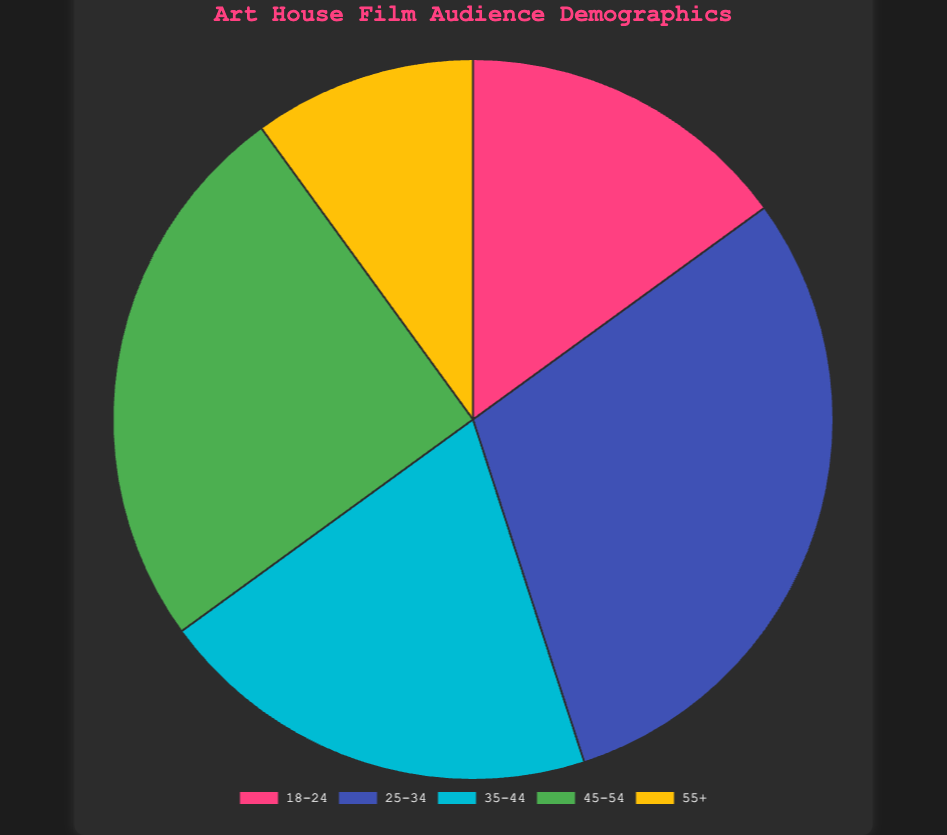What age group has the highest percentage in the audience demographic? The category with the highest percentage is "25-34" with 30%.
Answer: 25-34 Which age group has the smallest representation in the audience demographic? The category with the smallest percentage is "55+" with 10%.
Answer: 55+ What is the combined percentage of the "18-24" and "35-44" age groups? The "18-24" age group is 15% and the "35-44" age group is 20%. Combining these two percentages: 15% + 20% = 35%.
Answer: 35% How does the percentage of the "45-54" age group compare to the "55+" age group? The "45-54" age group is 25%, whereas the "55+" age group is 10%. So 25% is greater than 10%.
Answer: Greater What is the most common color representing the largest demographic? The largest demographic (25-34) is represented by the color associated with the second slice, which is blue.
Answer: Blue (25-34) Is the sum of the percentages for "25-34" and "55+" age groups less than 50%? The "25-34" age group is 30% and the "55+" age group is 10%. Summing these gives 30% + 10% = 40%, which is less than 50%.
Answer: Yes How does the "35-44" age group's percentage compare to the average percentage of all groups? The individual percentages are 15%, 30%, 20%, 25%, 10%. The average is (15 + 30 + 20 + 25 + 10) / 5 = 20%. The "35-44" age group is 20%, which equals the average percentage.
Answer: Equal If the "25-34" and "45-54" age groups are combined, what would their combined percentage be? "25-34" age group is 30%, and "45-54" age group is 25%. Combining these percentages: 30% + 25% = 55%.
Answer: 55% By how much does the largest age group exceed the smallest age group in percentage? The largest age group is "25-34" with 30%, and the smallest age group is "55+" with 10%. The difference is 30% - 10% = 20%.
Answer: 20% 